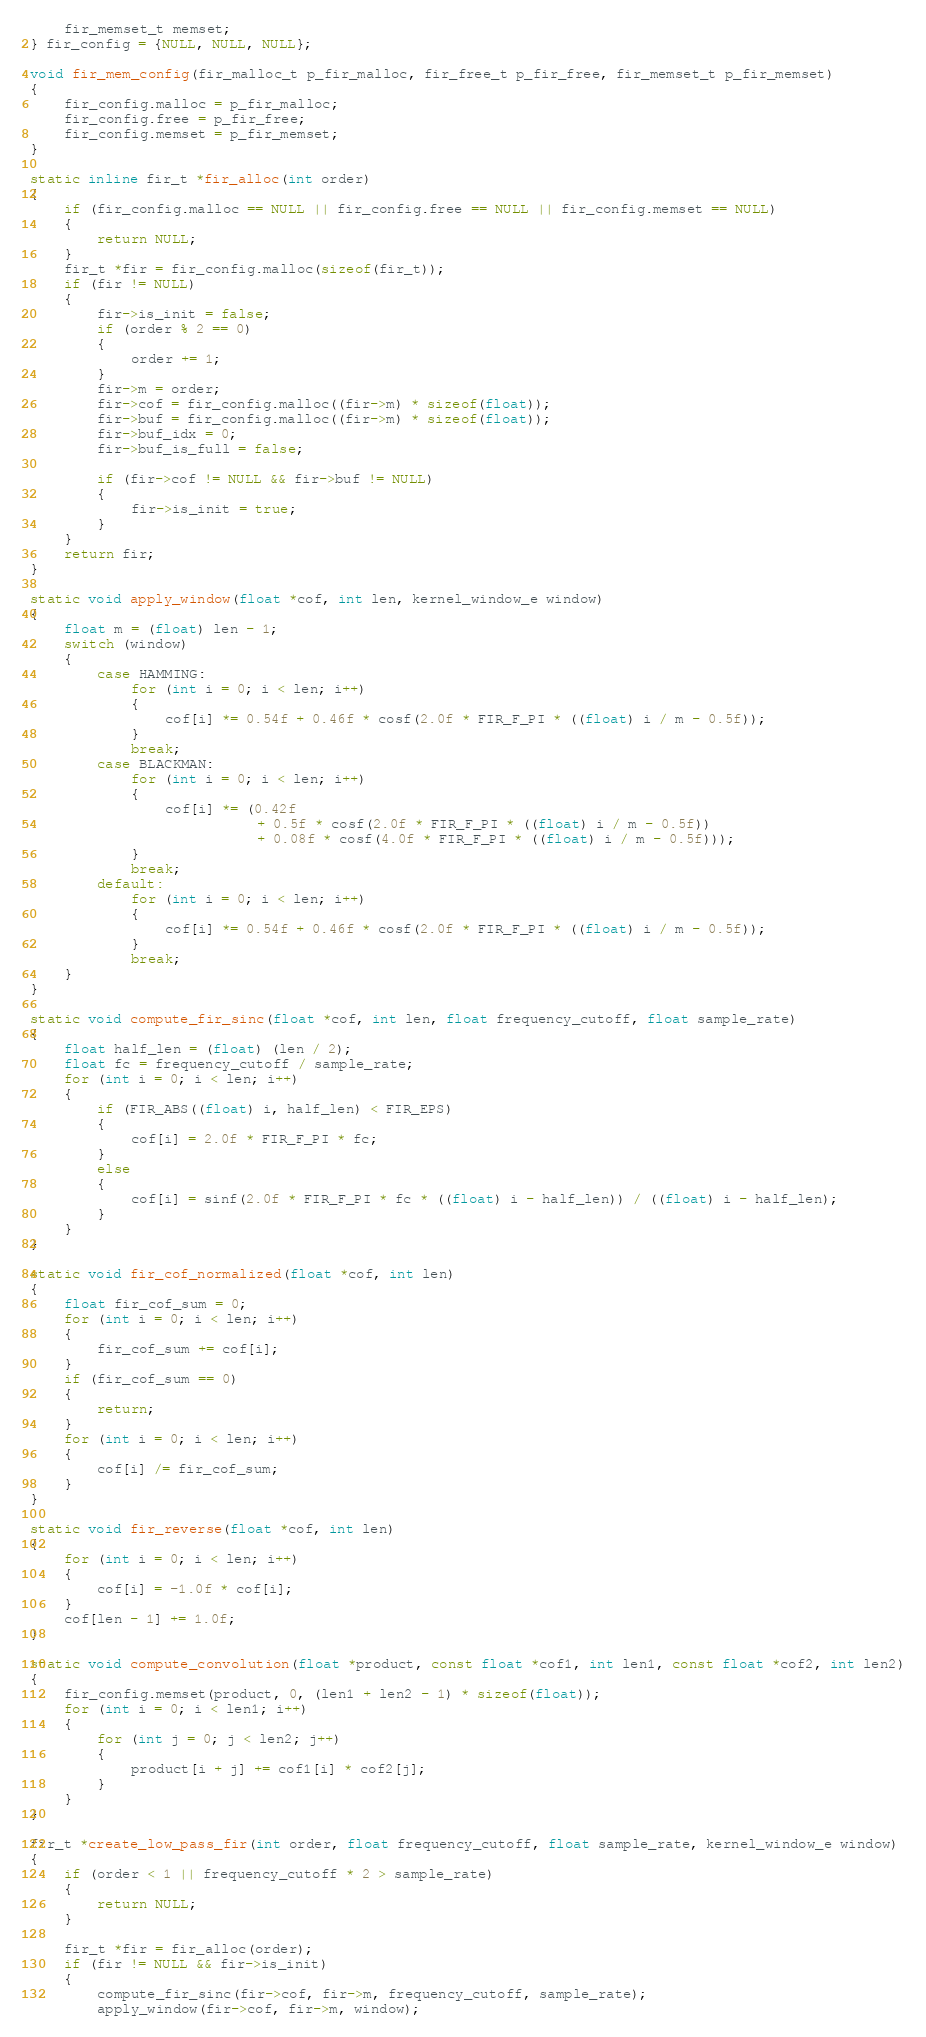<code> <loc_0><loc_0><loc_500><loc_500><_C_>    fir_memset_t memset;
} fir_config = {NULL, NULL, NULL};

void fir_mem_config(fir_malloc_t p_fir_malloc, fir_free_t p_fir_free, fir_memset_t p_fir_memset)
{
    fir_config.malloc = p_fir_malloc;
    fir_config.free = p_fir_free;
    fir_config.memset = p_fir_memset;
}

static inline fir_t *fir_alloc(int order)
{
    if (fir_config.malloc == NULL || fir_config.free == NULL || fir_config.memset == NULL)
    {
        return NULL;
    }
    fir_t *fir = fir_config.malloc(sizeof(fir_t));
    if (fir != NULL)
    {
        fir->is_init = false;
        if (order % 2 == 0)
        {
            order += 1;
        }
        fir->m = order;
        fir->cof = fir_config.malloc((fir->m) * sizeof(float));
        fir->buf = fir_config.malloc((fir->m) * sizeof(float));
        fir->buf_idx = 0;
        fir->buf_is_full = false;

        if (fir->cof != NULL && fir->buf != NULL)
        {
            fir->is_init = true;
        }
    }
    return fir;
}

static void apply_window(float *cof, int len, kernel_window_e window)
{
    float m = (float) len - 1;
    switch (window)
    {
        case HAMMING:
            for (int i = 0; i < len; i++)
            {
                cof[i] *= 0.54f + 0.46f * cosf(2.0f * FIR_F_PI * ((float) i / m - 0.5f));
            }
            break;
        case BLACKMAN:
            for (int i = 0; i < len; i++)
            {
                cof[i] *= (0.42f
                           + 0.5f * cosf(2.0f * FIR_F_PI * ((float) i / m - 0.5f))
                           + 0.08f * cosf(4.0f * FIR_F_PI * ((float) i / m - 0.5f)));
            }
            break;
        default:
            for (int i = 0; i < len; i++)
            {
                cof[i] *= 0.54f + 0.46f * cosf(2.0f * FIR_F_PI * ((float) i / m - 0.5f));
            }
            break;
    }
}

static void compute_fir_sinc(float *cof, int len, float frequency_cutoff, float sample_rate)
{
    float half_len = (float) (len / 2);
    float fc = frequency_cutoff / sample_rate;
    for (int i = 0; i < len; i++)
    {
        if (FIR_ABS((float) i, half_len) < FIR_EPS)
        {
            cof[i] = 2.0f * FIR_F_PI * fc;
        }
        else
        {
            cof[i] = sinf(2.0f * FIR_F_PI * fc * ((float) i - half_len)) / ((float) i - half_len);
        }
    }
}

static void fir_cof_normalized(float *cof, int len)
{
    float fir_cof_sum = 0;
    for (int i = 0; i < len; i++)
    {
        fir_cof_sum += cof[i];
    }
    if (fir_cof_sum == 0)
    {
        return;
    }
    for (int i = 0; i < len; i++)
    {
        cof[i] /= fir_cof_sum;
    }
}

static void fir_reverse(float *cof, int len)
{
    for (int i = 0; i < len; i++)
    {
        cof[i] = -1.0f * cof[i];
    }
    cof[len - 1] += 1.0f;
}

static void compute_convolution(float *product, const float *cof1, int len1, const float *cof2, int len2)
{
    fir_config.memset(product, 0, (len1 + len2 - 1) * sizeof(float));
    for (int i = 0; i < len1; i++)
    {
        for (int j = 0; j < len2; j++)
        {
            product[i + j] += cof1[i] * cof2[j];
        }
    }
}

fir_t *create_low_pass_fir(int order, float frequency_cutoff, float sample_rate, kernel_window_e window)
{
    if (order < 1 || frequency_cutoff * 2 > sample_rate)
    {
        return NULL;
    }

    fir_t *fir = fir_alloc(order);
    if (fir != NULL && fir->is_init)
    {
        compute_fir_sinc(fir->cof, fir->m, frequency_cutoff, sample_rate);
        apply_window(fir->cof, fir->m, window);</code> 